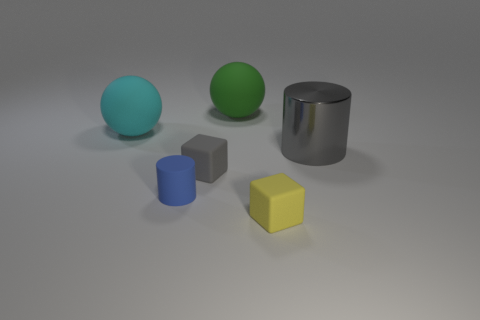Is the size of the blue matte cylinder the same as the matte cube right of the gray block?
Provide a succinct answer. Yes. What is the color of the small thing that is right of the rubber sphere that is right of the tiny blue cylinder?
Keep it short and to the point. Yellow. Is the matte cylinder the same size as the gray block?
Ensure brevity in your answer.  Yes. What color is the rubber thing that is both in front of the large cyan object and on the right side of the small gray rubber block?
Your response must be concise. Yellow. What is the size of the green matte sphere?
Give a very brief answer. Large. Do the cylinder in front of the metallic thing and the large cylinder have the same color?
Keep it short and to the point. No. Are there more cubes left of the small yellow matte thing than large gray metal objects that are in front of the tiny gray cube?
Provide a short and direct response. Yes. Is the number of tiny cubes greater than the number of green matte objects?
Provide a succinct answer. Yes. There is a thing that is both in front of the tiny gray matte cube and behind the yellow rubber thing; how big is it?
Ensure brevity in your answer.  Small. What is the shape of the metallic thing?
Keep it short and to the point. Cylinder. 